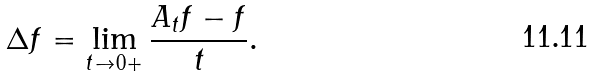<formula> <loc_0><loc_0><loc_500><loc_500>\Delta f = \lim _ { t \to 0 + } \frac { A _ { t } f - f } t .</formula> 